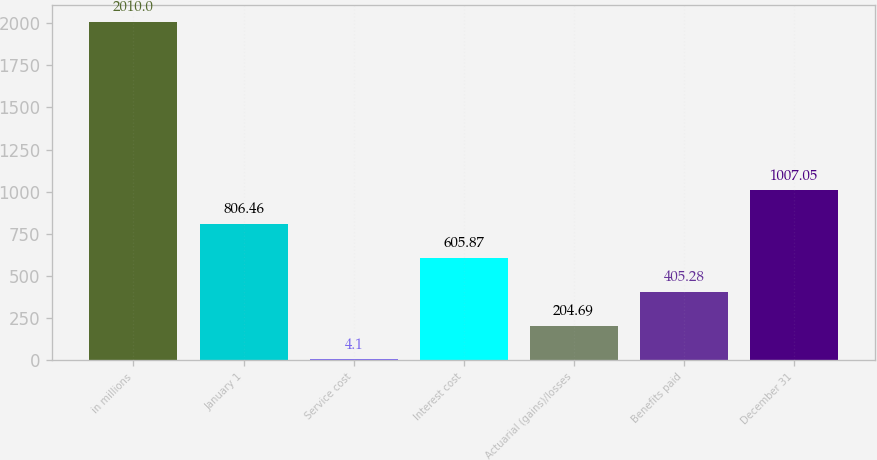Convert chart to OTSL. <chart><loc_0><loc_0><loc_500><loc_500><bar_chart><fcel>in millions<fcel>January 1<fcel>Service cost<fcel>Interest cost<fcel>Actuarial (gains)/losses<fcel>Benefits paid<fcel>December 31<nl><fcel>2010<fcel>806.46<fcel>4.1<fcel>605.87<fcel>204.69<fcel>405.28<fcel>1007.05<nl></chart> 